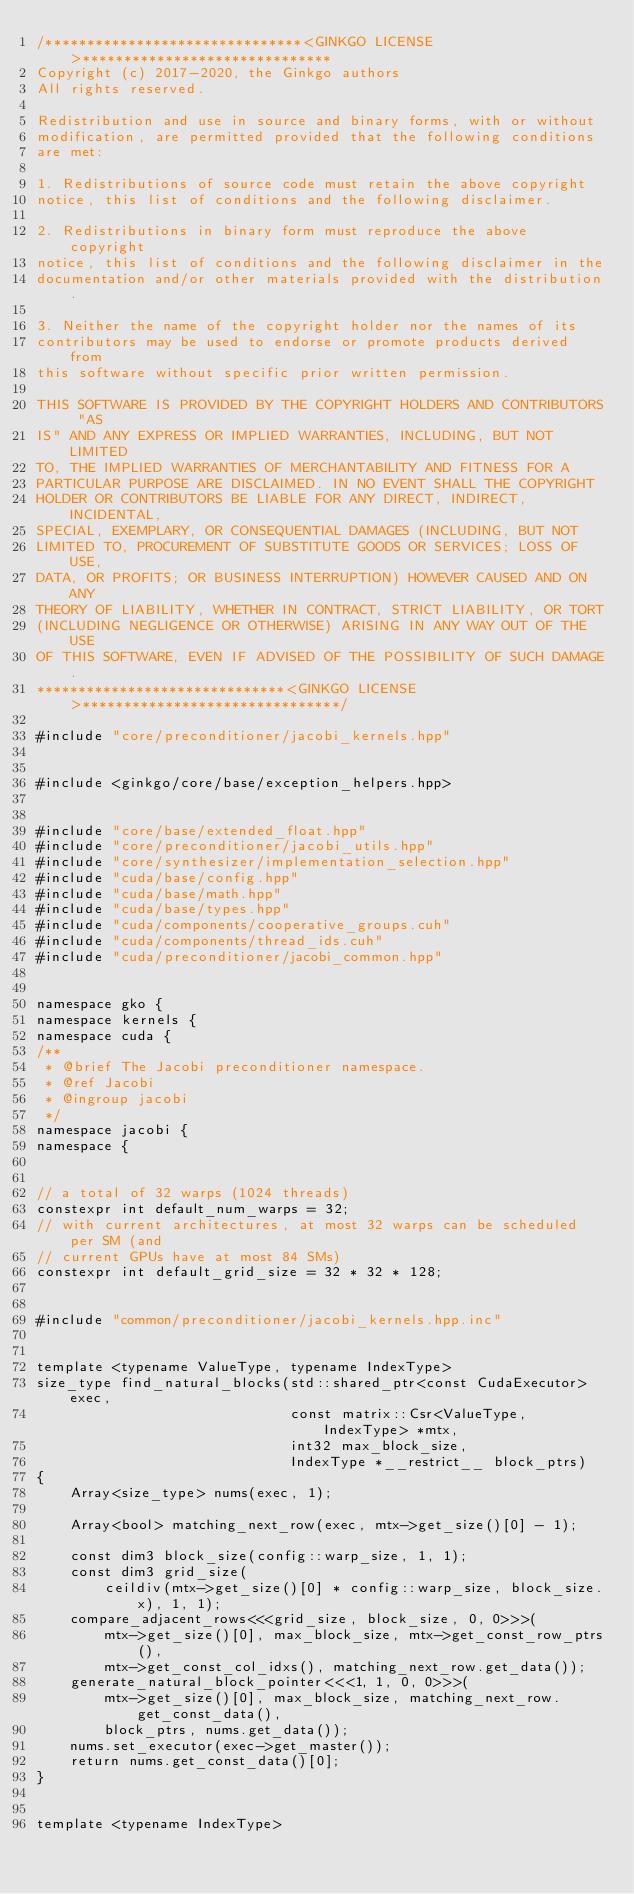<code> <loc_0><loc_0><loc_500><loc_500><_Cuda_>/*******************************<GINKGO LICENSE>******************************
Copyright (c) 2017-2020, the Ginkgo authors
All rights reserved.

Redistribution and use in source and binary forms, with or without
modification, are permitted provided that the following conditions
are met:

1. Redistributions of source code must retain the above copyright
notice, this list of conditions and the following disclaimer.

2. Redistributions in binary form must reproduce the above copyright
notice, this list of conditions and the following disclaimer in the
documentation and/or other materials provided with the distribution.

3. Neither the name of the copyright holder nor the names of its
contributors may be used to endorse or promote products derived from
this software without specific prior written permission.

THIS SOFTWARE IS PROVIDED BY THE COPYRIGHT HOLDERS AND CONTRIBUTORS "AS
IS" AND ANY EXPRESS OR IMPLIED WARRANTIES, INCLUDING, BUT NOT LIMITED
TO, THE IMPLIED WARRANTIES OF MERCHANTABILITY AND FITNESS FOR A
PARTICULAR PURPOSE ARE DISCLAIMED. IN NO EVENT SHALL THE COPYRIGHT
HOLDER OR CONTRIBUTORS BE LIABLE FOR ANY DIRECT, INDIRECT, INCIDENTAL,
SPECIAL, EXEMPLARY, OR CONSEQUENTIAL DAMAGES (INCLUDING, BUT NOT
LIMITED TO, PROCUREMENT OF SUBSTITUTE GOODS OR SERVICES; LOSS OF USE,
DATA, OR PROFITS; OR BUSINESS INTERRUPTION) HOWEVER CAUSED AND ON ANY
THEORY OF LIABILITY, WHETHER IN CONTRACT, STRICT LIABILITY, OR TORT
(INCLUDING NEGLIGENCE OR OTHERWISE) ARISING IN ANY WAY OUT OF THE USE
OF THIS SOFTWARE, EVEN IF ADVISED OF THE POSSIBILITY OF SUCH DAMAGE.
******************************<GINKGO LICENSE>*******************************/

#include "core/preconditioner/jacobi_kernels.hpp"


#include <ginkgo/core/base/exception_helpers.hpp>


#include "core/base/extended_float.hpp"
#include "core/preconditioner/jacobi_utils.hpp"
#include "core/synthesizer/implementation_selection.hpp"
#include "cuda/base/config.hpp"
#include "cuda/base/math.hpp"
#include "cuda/base/types.hpp"
#include "cuda/components/cooperative_groups.cuh"
#include "cuda/components/thread_ids.cuh"
#include "cuda/preconditioner/jacobi_common.hpp"


namespace gko {
namespace kernels {
namespace cuda {
/**
 * @brief The Jacobi preconditioner namespace.
 * @ref Jacobi
 * @ingroup jacobi
 */
namespace jacobi {
namespace {


// a total of 32 warps (1024 threads)
constexpr int default_num_warps = 32;
// with current architectures, at most 32 warps can be scheduled per SM (and
// current GPUs have at most 84 SMs)
constexpr int default_grid_size = 32 * 32 * 128;


#include "common/preconditioner/jacobi_kernels.hpp.inc"


template <typename ValueType, typename IndexType>
size_type find_natural_blocks(std::shared_ptr<const CudaExecutor> exec,
                              const matrix::Csr<ValueType, IndexType> *mtx,
                              int32 max_block_size,
                              IndexType *__restrict__ block_ptrs)
{
    Array<size_type> nums(exec, 1);

    Array<bool> matching_next_row(exec, mtx->get_size()[0] - 1);

    const dim3 block_size(config::warp_size, 1, 1);
    const dim3 grid_size(
        ceildiv(mtx->get_size()[0] * config::warp_size, block_size.x), 1, 1);
    compare_adjacent_rows<<<grid_size, block_size, 0, 0>>>(
        mtx->get_size()[0], max_block_size, mtx->get_const_row_ptrs(),
        mtx->get_const_col_idxs(), matching_next_row.get_data());
    generate_natural_block_pointer<<<1, 1, 0, 0>>>(
        mtx->get_size()[0], max_block_size, matching_next_row.get_const_data(),
        block_ptrs, nums.get_data());
    nums.set_executor(exec->get_master());
    return nums.get_const_data()[0];
}


template <typename IndexType></code> 